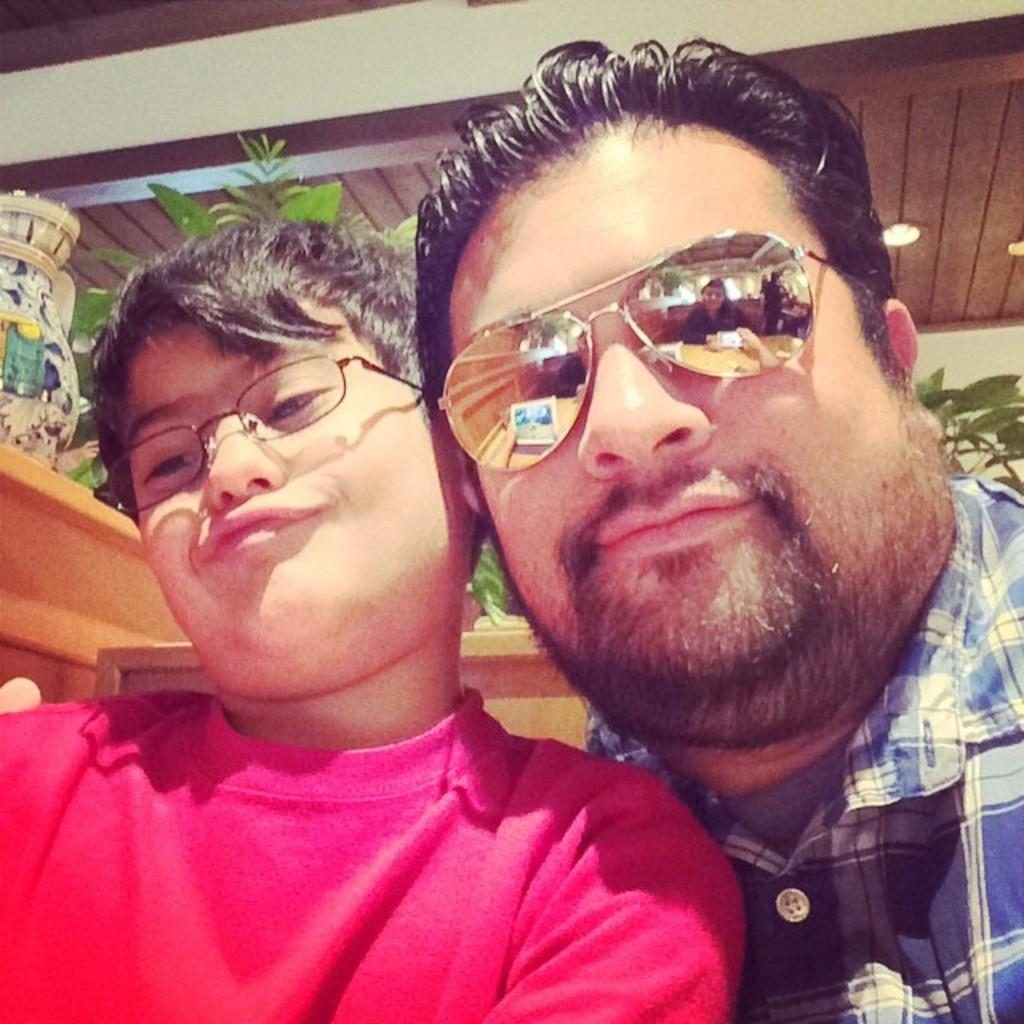How many people are present in the image? There are two people in the image. What is located behind the people? There are plants behind the people. What object can be seen on a platform in the image? There is a pot on a platform in the image. What type of illumination is visible at the top of the image? There is a light visible at the top of the image. How many steps does it take to reach the clouds in the image? There are no clouds visible in the image, and therefore no steps can be taken to reach them. 